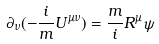Convert formula to latex. <formula><loc_0><loc_0><loc_500><loc_500>\partial _ { \nu } ( - \frac { i } { m } U ^ { \mu \nu } ) = \frac { m } { i } R ^ { \mu } \psi</formula> 